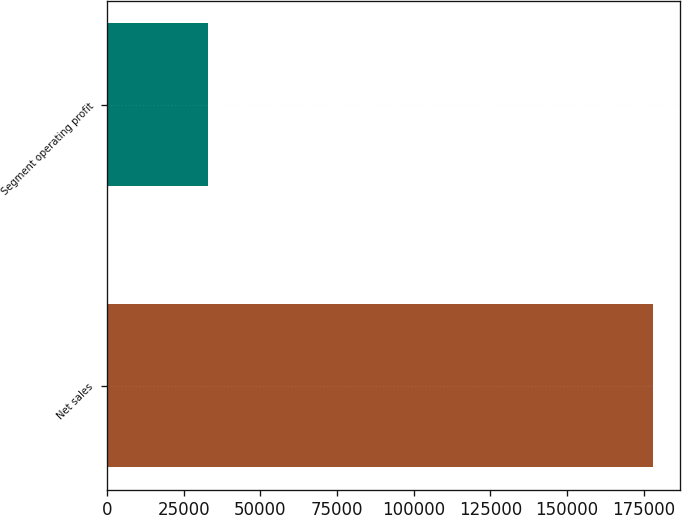<chart> <loc_0><loc_0><loc_500><loc_500><bar_chart><fcel>Net sales<fcel>Segment operating profit<nl><fcel>177945<fcel>32859<nl></chart> 